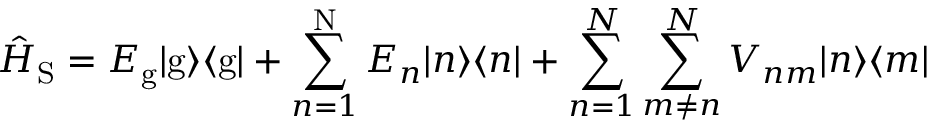Convert formula to latex. <formula><loc_0><loc_0><loc_500><loc_500>\hat { H } _ { S } = E _ { g } | g \rangle \langle { g } | + \sum _ { n = 1 } ^ { N } E _ { n } | n \rangle \langle { n } | + { \sum _ { n = 1 } ^ { N } } \sum _ { m \neq n } ^ { N } V _ { n m } | n \rangle \langle { m } |</formula> 